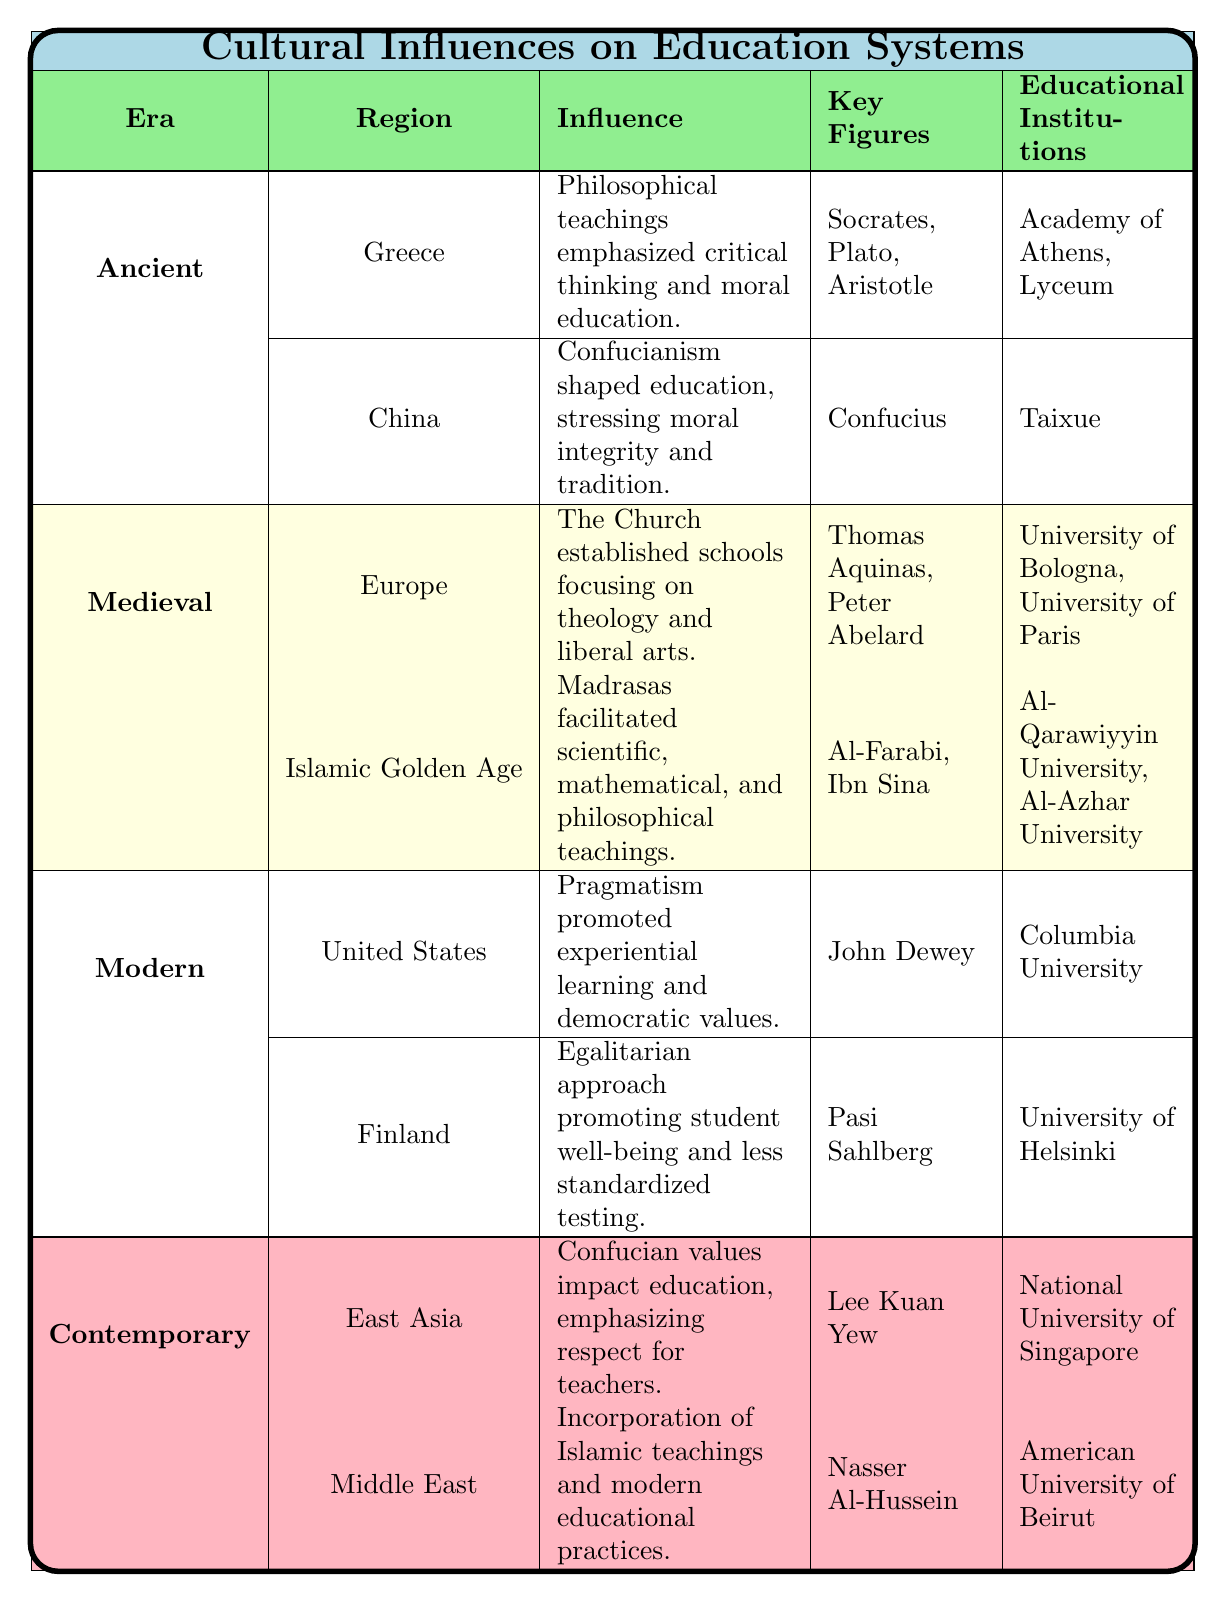What cultural influence shaped the education system in Greece during the Ancient era? According to the table, the cultural influence in Greece during the Ancient era was philosophical teachings by Socrates, Plato, and Aristotle, which emphasized critical thinking and moral education.
Answer: Philosophical teachings by Socrates, Plato, and Aristotle What key figure is associated with the educational influence in China? The table specifies that Confucius is the key figure associated with the cultural influence in China's education system during the Ancient era.
Answer: Confucius Which two educational institutions were established in Europe during the Medieval period? The table lists the University of Bologna and the University of Paris as the educational institutions established in Europe during the Medieval period.
Answer: University of Bologna, University of Paris What was the primary focus of the Church in education during the Medieval era in Europe? The table indicates that the Church established schools focusing on theology and liberal arts in Europe during the Medieval era.
Answer: Theology and liberal arts Which region's education system was influenced by pragmatism in the Modern era? The United States is mentioned in the table as the region influenced by pragmatism, promoting experiential learning and democratic values.
Answer: United States Which key figure is linked to Finland's educational influence in the Modern era? The table states that Pasi Sahlberg is the key figure associated with the egalitarian approach to education in Finland during the Modern era.
Answer: Pasi Sahlberg What was a notable characteristic of the educational institutions in the Middle East during the Contemporary period? The table highlights that educational institutions in the Middle East incorporated both traditional Islamic teachings and modern educational practices to improve literacy and critical thinking.
Answer: Incorporation of traditional Islamic teachings and modern practices Count the number of key figures mentioned in the Ancient era. From the table, the key figures in the Ancient era are Socrates, Plato, Aristotle for Greece, and Confucius for China, totaling four key figures.
Answer: 4 Is the influence of Confucian values present in both Ancient China and Contemporary East Asia? Yes, the table confirms that Confucianism influenced education in both Ancient China and continues to impact the education system in Contemporary East Asia.
Answer: Yes Which region's educational approach emphasizes less standardized testing in the Modern era? The table specifically states that Finland's educational approach emphasizes less standardized testing as part of its egalitarian values.
Answer: Finland 